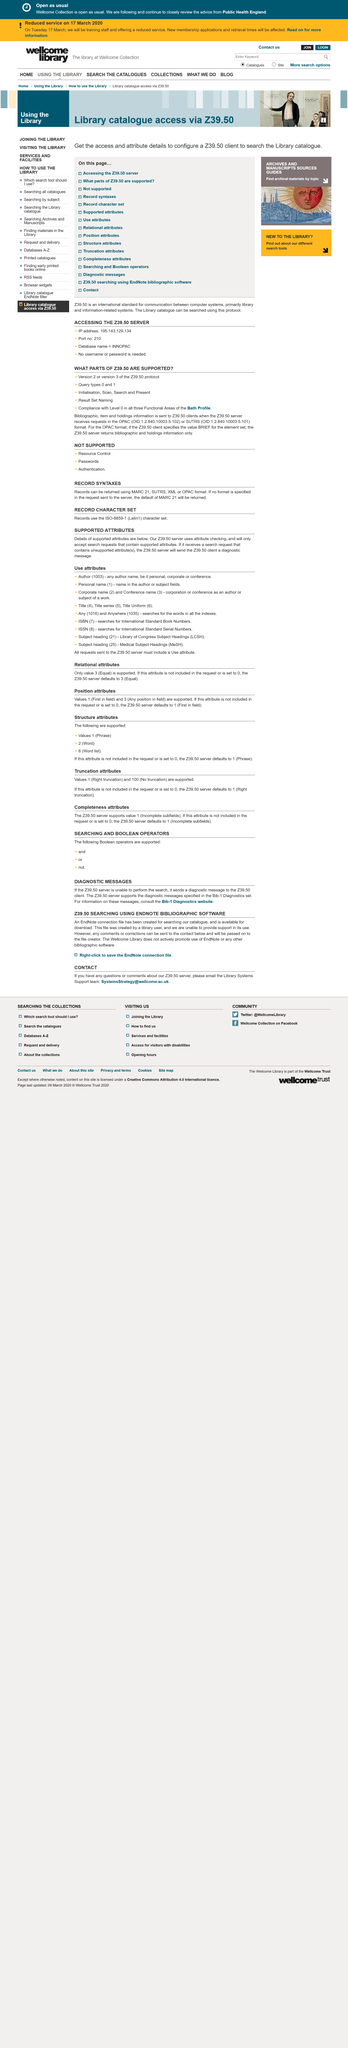Give some essential details in this illustration. If a Z39.50 server receives a search request that includes unsorted attributes, it will respond with a diagnostic message. The character set used for the records is ISO-8859-1, also known as Latin 1. The page contains two headlines. Yes, a downloadable EndNote connection file is available. The headline "DIAGNOSTIC MESSAGES" is the first. 